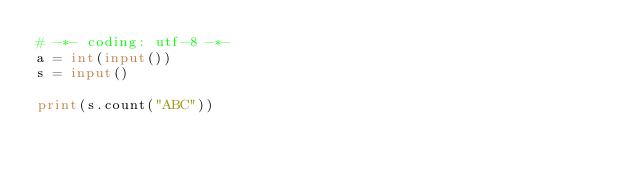Convert code to text. <code><loc_0><loc_0><loc_500><loc_500><_Python_># -*- coding: utf-8 -*-
a = int(input())
s = input()

print(s.count("ABC"))</code> 